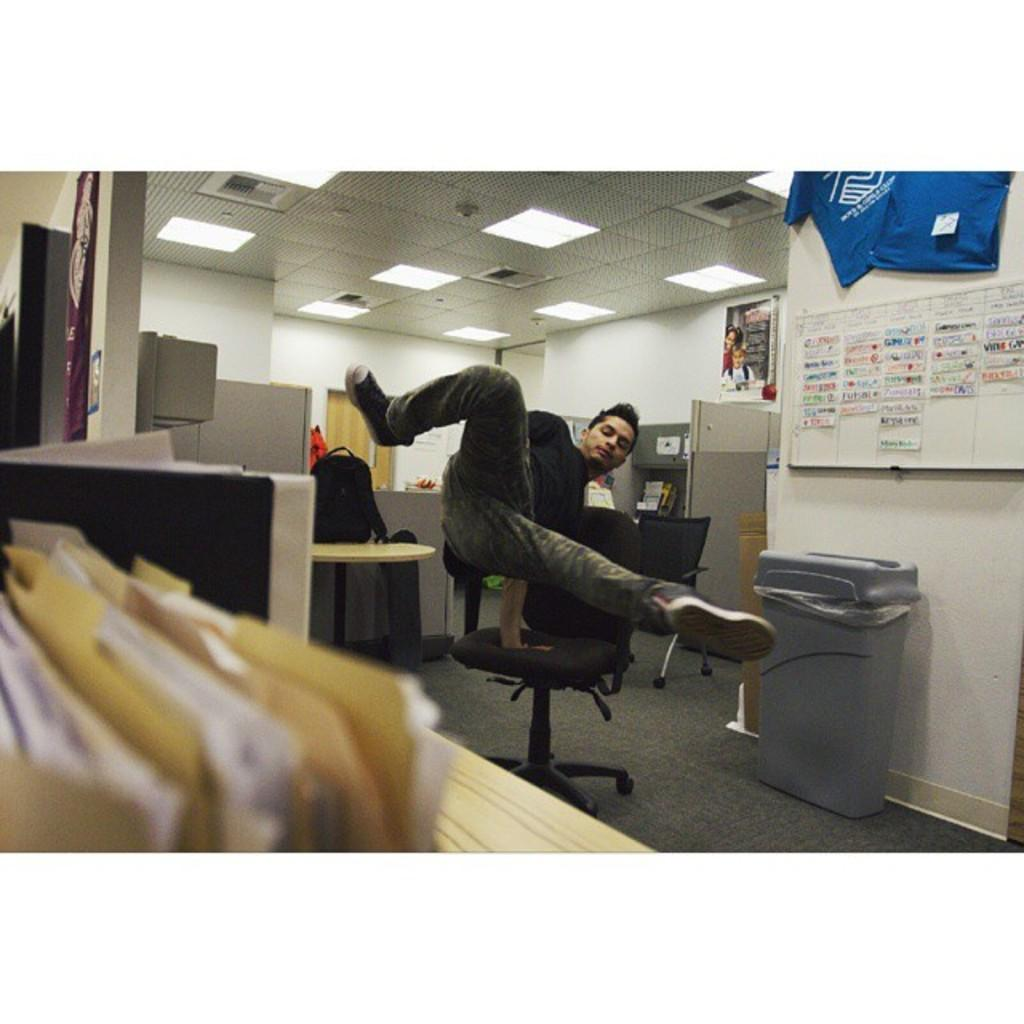Who is present in the image? There is a man in the image. What object can be seen for waste disposal? There is a dustbin in the image. What is used for displaying notices or announcements? There is a notice board in the image. What type of items are present in the image related to documentation? There are files with paper in the image. What is above the scene in the image? There is a ceiling in the image. Can you describe the lighting conditions in the image? There is some light in the image. What type of jelly can be seen on the ceiling in the image? There is no jelly present on the ceiling in the image. How does the man use the spade in the image? There is no spade present in the image, so it cannot be used by the man. 